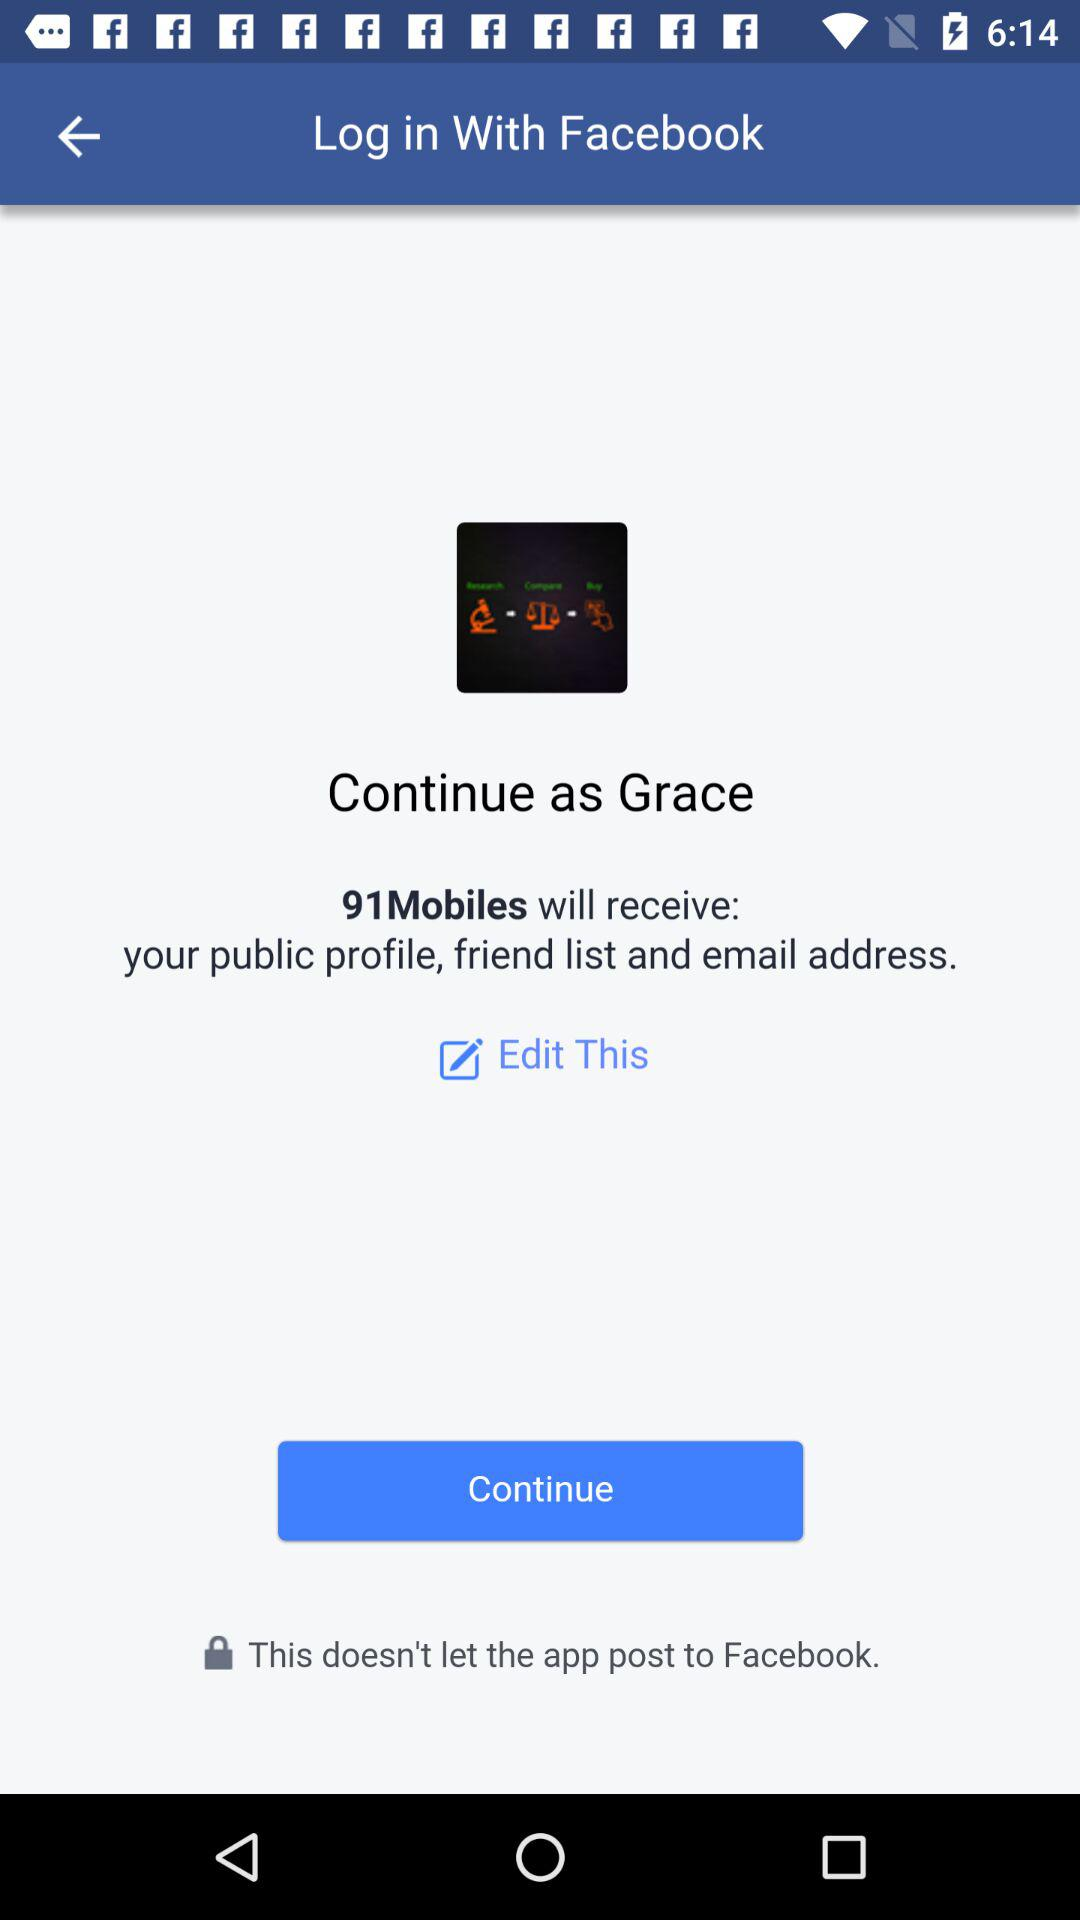What application can be used to log in? The application that can be used to log in is "Facebook". 